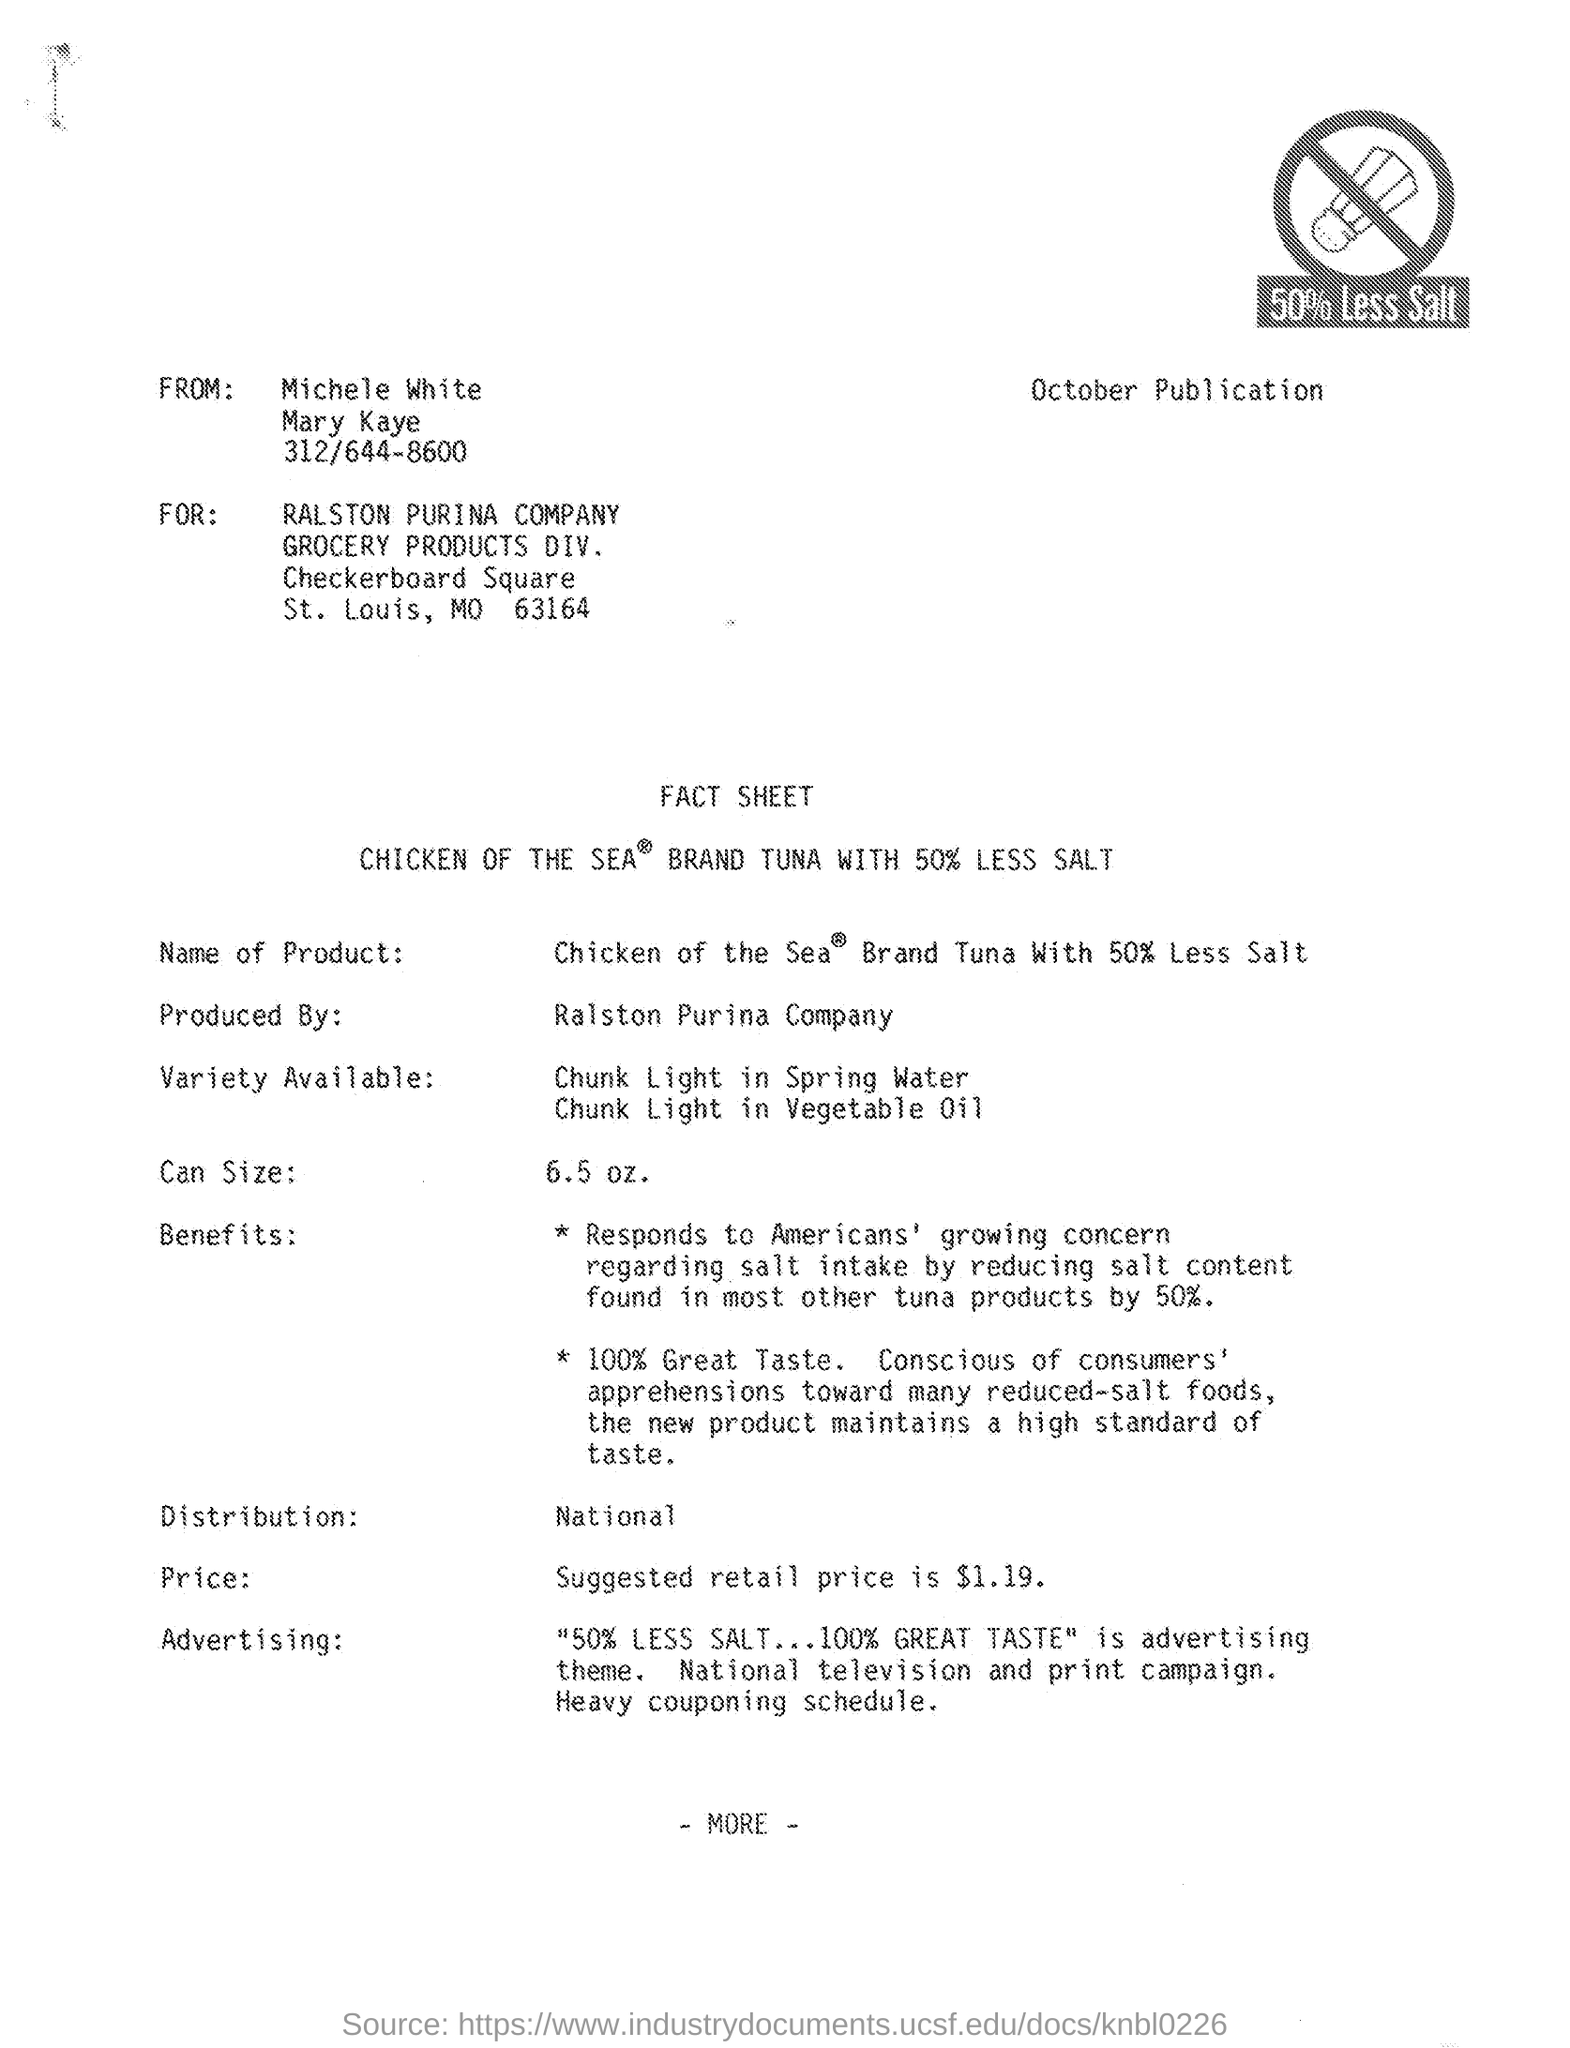From whom the sheet was delivered ?
Keep it short and to the point. Michele White. For which company it was published ?
Ensure brevity in your answer.  Ralston Purina Company. What is the div. mentioned ?
Make the answer very short. Grocery Products Div. What is the name of the product mentioned in the fact sheet ?
Make the answer very short. Chicken of the Sea Brand Tuna With 50% less salt. What is the can size mentioned in the given fact sheet ?
Your answer should be very brief. 6.5 oz. What is the distribution level mentioned in the given fact sheet ?
Keep it short and to the point. National. What is the price mentioned in the given fact sheet ?
Keep it short and to the point. Suggested retail price is $ 1.19. 